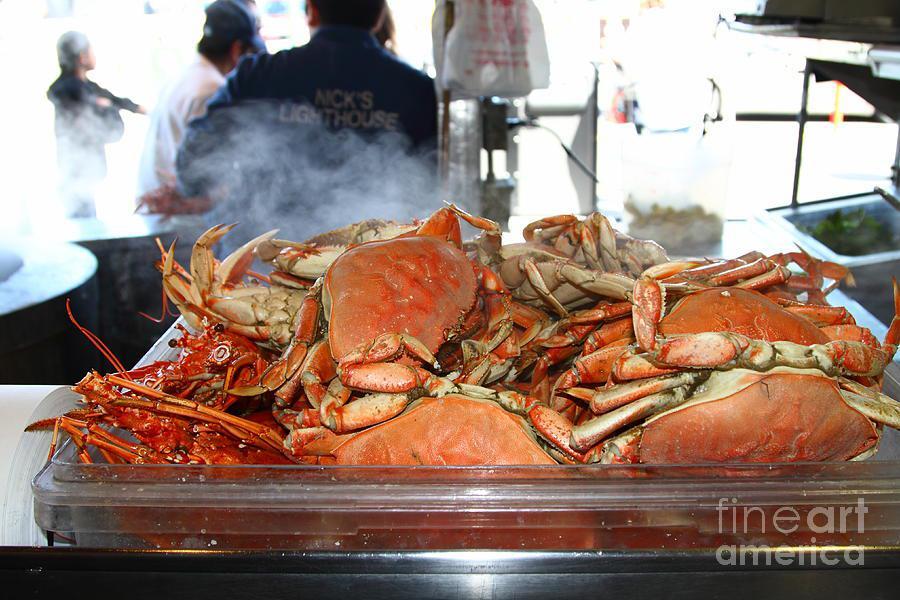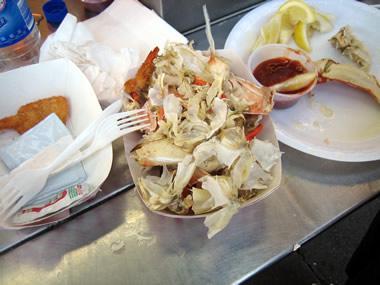The first image is the image on the left, the second image is the image on the right. Examine the images to the left and right. Is the description "In the left image, a man in an apron is behind a counter containing piles of upside-down crabs." accurate? Answer yes or no. No. 